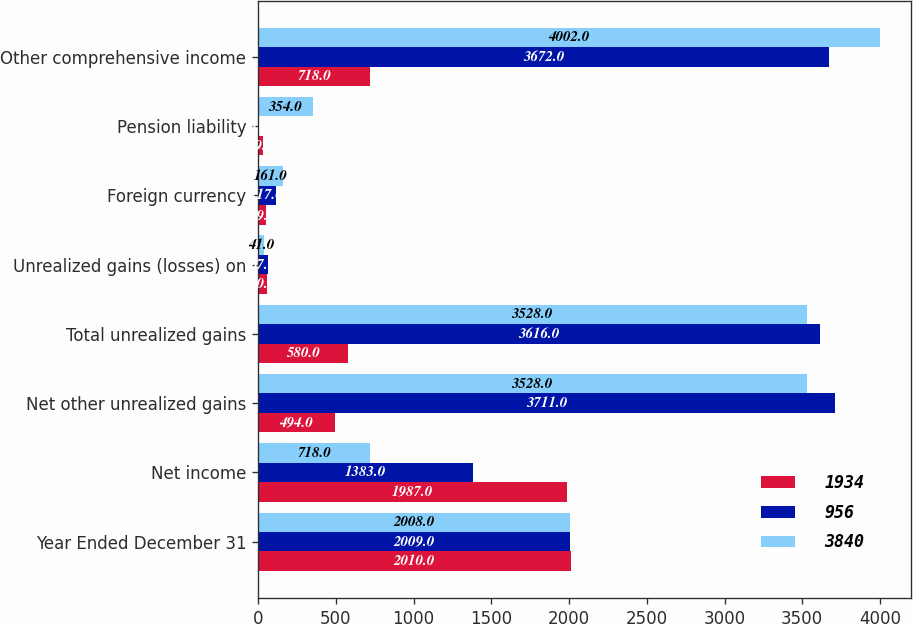Convert chart to OTSL. <chart><loc_0><loc_0><loc_500><loc_500><stacked_bar_chart><ecel><fcel>Year Ended December 31<fcel>Net income<fcel>Net other unrealized gains<fcel>Total unrealized gains<fcel>Unrealized gains (losses) on<fcel>Foreign currency<fcel>Pension liability<fcel>Other comprehensive income<nl><fcel>1934<fcel>2010<fcel>1987<fcel>494<fcel>580<fcel>60<fcel>49<fcel>29<fcel>718<nl><fcel>956<fcel>2009<fcel>1383<fcel>3711<fcel>3616<fcel>67<fcel>117<fcel>6<fcel>3672<nl><fcel>3840<fcel>2008<fcel>718<fcel>3528<fcel>3528<fcel>41<fcel>161<fcel>354<fcel>4002<nl></chart> 